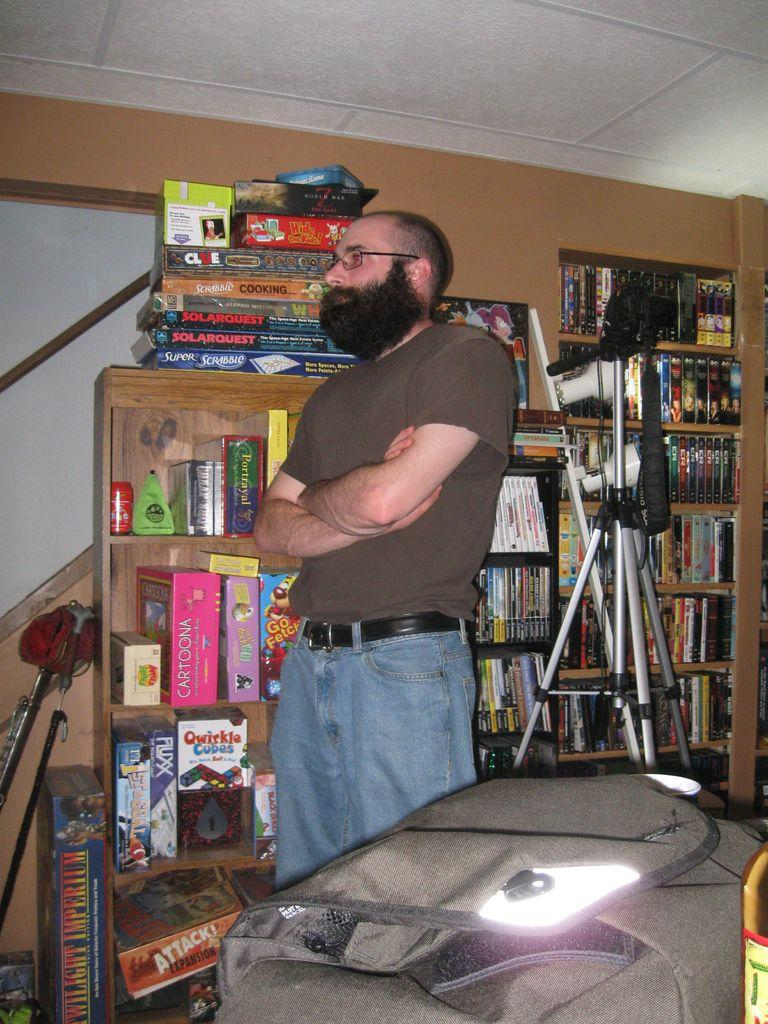<image>
Provide a brief description of the given image. a man standing in front of a shelf of games with one called 'super scrabble' 